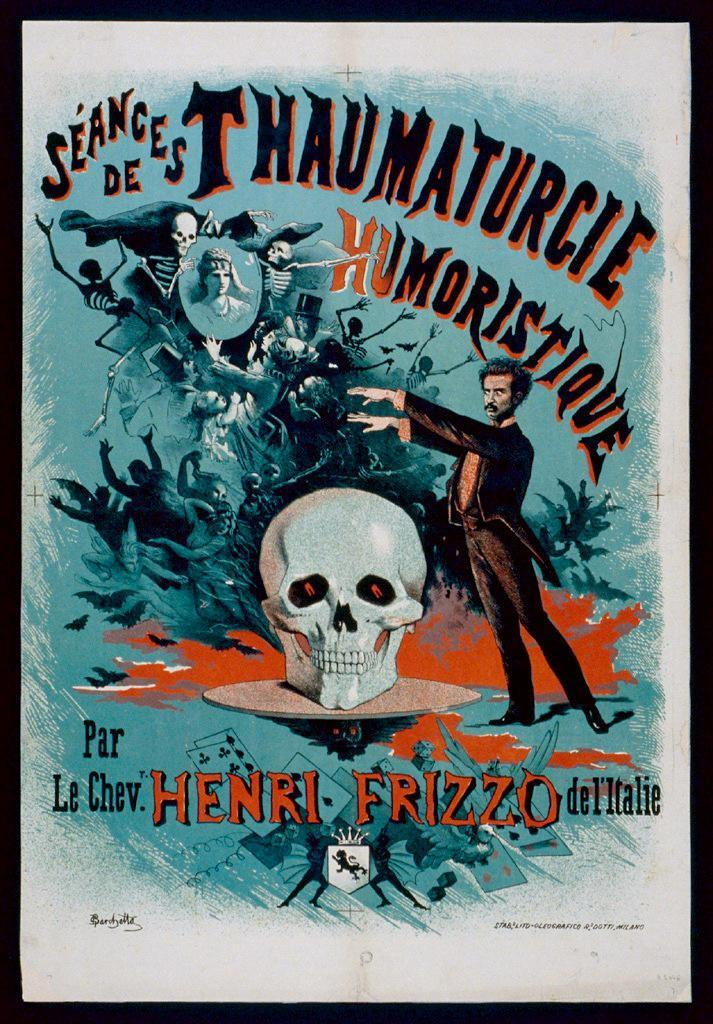<image>
Provide a brief description of the given image. A sign with the name Henri on it 